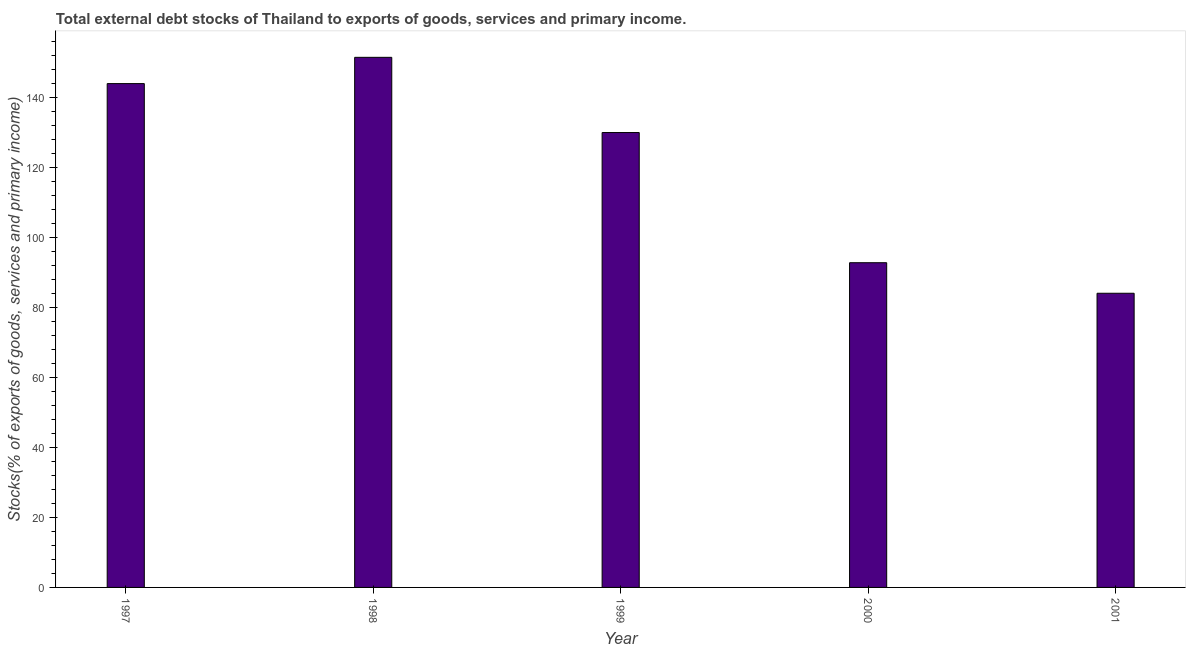Does the graph contain any zero values?
Keep it short and to the point. No. What is the title of the graph?
Offer a terse response. Total external debt stocks of Thailand to exports of goods, services and primary income. What is the label or title of the X-axis?
Offer a terse response. Year. What is the label or title of the Y-axis?
Give a very brief answer. Stocks(% of exports of goods, services and primary income). What is the external debt stocks in 1998?
Offer a very short reply. 151.54. Across all years, what is the maximum external debt stocks?
Offer a very short reply. 151.54. Across all years, what is the minimum external debt stocks?
Give a very brief answer. 84.1. What is the sum of the external debt stocks?
Provide a short and direct response. 602.55. What is the difference between the external debt stocks in 1997 and 2001?
Provide a short and direct response. 59.94. What is the average external debt stocks per year?
Offer a terse response. 120.51. What is the median external debt stocks?
Your answer should be compact. 130.04. In how many years, is the external debt stocks greater than 108 %?
Your answer should be very brief. 3. What is the ratio of the external debt stocks in 1999 to that in 2000?
Provide a short and direct response. 1.4. Is the external debt stocks in 1999 less than that in 2001?
Give a very brief answer. No. Is the difference between the external debt stocks in 1997 and 2000 greater than the difference between any two years?
Offer a terse response. No. What is the difference between the highest and the second highest external debt stocks?
Your response must be concise. 7.51. Is the sum of the external debt stocks in 1999 and 2000 greater than the maximum external debt stocks across all years?
Your answer should be very brief. Yes. What is the difference between the highest and the lowest external debt stocks?
Your answer should be compact. 67.45. In how many years, is the external debt stocks greater than the average external debt stocks taken over all years?
Provide a succinct answer. 3. How many bars are there?
Your response must be concise. 5. What is the Stocks(% of exports of goods, services and primary income) in 1997?
Give a very brief answer. 144.03. What is the Stocks(% of exports of goods, services and primary income) in 1998?
Offer a terse response. 151.54. What is the Stocks(% of exports of goods, services and primary income) of 1999?
Your answer should be compact. 130.04. What is the Stocks(% of exports of goods, services and primary income) of 2000?
Your response must be concise. 92.83. What is the Stocks(% of exports of goods, services and primary income) of 2001?
Your response must be concise. 84.1. What is the difference between the Stocks(% of exports of goods, services and primary income) in 1997 and 1998?
Give a very brief answer. -7.51. What is the difference between the Stocks(% of exports of goods, services and primary income) in 1997 and 1999?
Your answer should be compact. 13.99. What is the difference between the Stocks(% of exports of goods, services and primary income) in 1997 and 2000?
Your answer should be very brief. 51.21. What is the difference between the Stocks(% of exports of goods, services and primary income) in 1997 and 2001?
Provide a succinct answer. 59.94. What is the difference between the Stocks(% of exports of goods, services and primary income) in 1998 and 1999?
Give a very brief answer. 21.5. What is the difference between the Stocks(% of exports of goods, services and primary income) in 1998 and 2000?
Your response must be concise. 58.71. What is the difference between the Stocks(% of exports of goods, services and primary income) in 1998 and 2001?
Offer a terse response. 67.45. What is the difference between the Stocks(% of exports of goods, services and primary income) in 1999 and 2000?
Offer a terse response. 37.22. What is the difference between the Stocks(% of exports of goods, services and primary income) in 1999 and 2001?
Your answer should be very brief. 45.95. What is the difference between the Stocks(% of exports of goods, services and primary income) in 2000 and 2001?
Your answer should be very brief. 8.73. What is the ratio of the Stocks(% of exports of goods, services and primary income) in 1997 to that in 1999?
Give a very brief answer. 1.11. What is the ratio of the Stocks(% of exports of goods, services and primary income) in 1997 to that in 2000?
Ensure brevity in your answer.  1.55. What is the ratio of the Stocks(% of exports of goods, services and primary income) in 1997 to that in 2001?
Provide a succinct answer. 1.71. What is the ratio of the Stocks(% of exports of goods, services and primary income) in 1998 to that in 1999?
Keep it short and to the point. 1.17. What is the ratio of the Stocks(% of exports of goods, services and primary income) in 1998 to that in 2000?
Ensure brevity in your answer.  1.63. What is the ratio of the Stocks(% of exports of goods, services and primary income) in 1998 to that in 2001?
Your response must be concise. 1.8. What is the ratio of the Stocks(% of exports of goods, services and primary income) in 1999 to that in 2000?
Offer a very short reply. 1.4. What is the ratio of the Stocks(% of exports of goods, services and primary income) in 1999 to that in 2001?
Provide a short and direct response. 1.55. What is the ratio of the Stocks(% of exports of goods, services and primary income) in 2000 to that in 2001?
Give a very brief answer. 1.1. 